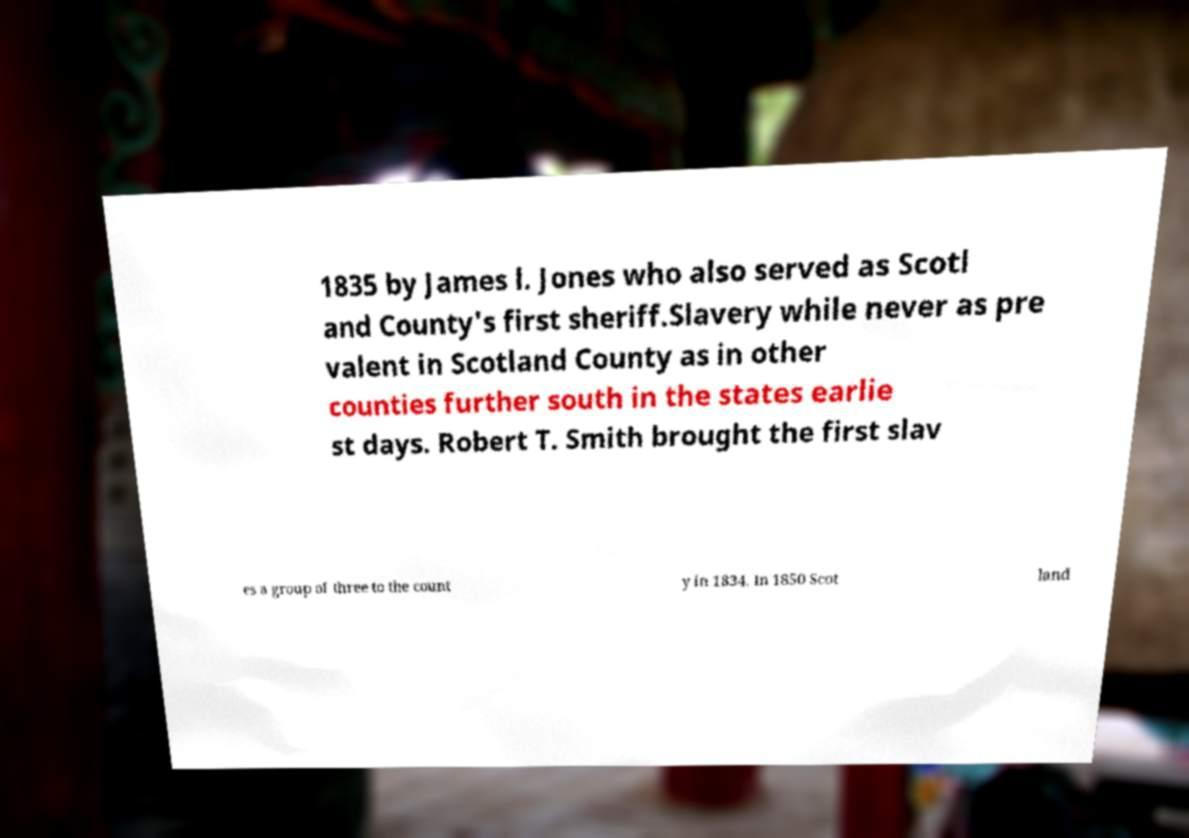Could you extract and type out the text from this image? 1835 by James l. Jones who also served as Scotl and County's first sheriff.Slavery while never as pre valent in Scotland County as in other counties further south in the states earlie st days. Robert T. Smith brought the first slav es a group of three to the count y in 1834. In 1850 Scot land 